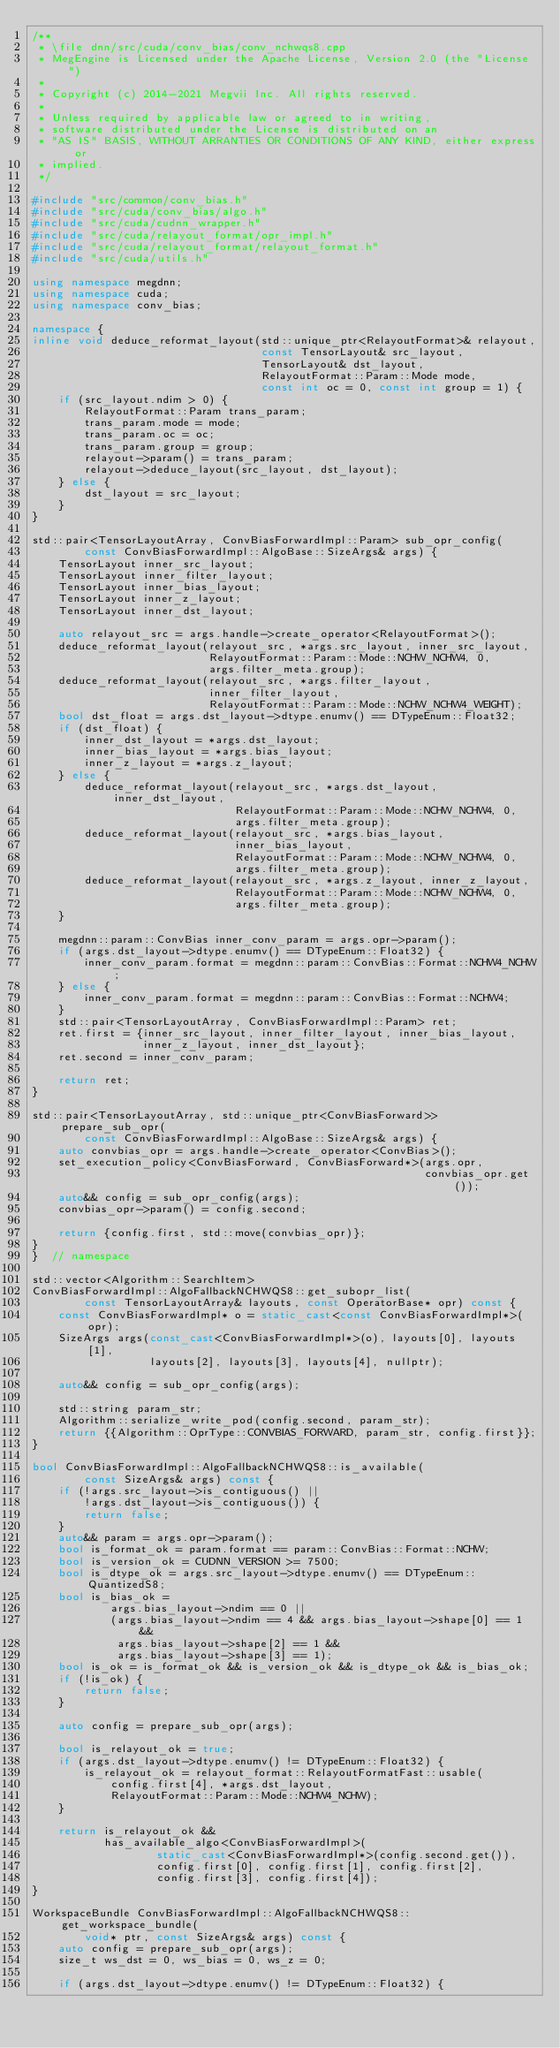Convert code to text. <code><loc_0><loc_0><loc_500><loc_500><_C++_>/**
 * \file dnn/src/cuda/conv_bias/conv_nchwqs8.cpp
 * MegEngine is Licensed under the Apache License, Version 2.0 (the "License")
 *
 * Copyright (c) 2014-2021 Megvii Inc. All rights reserved.
 *
 * Unless required by applicable law or agreed to in writing,
 * software distributed under the License is distributed on an
 * "AS IS" BASIS, WITHOUT ARRANTIES OR CONDITIONS OF ANY KIND, either express or
 * implied.
 */

#include "src/common/conv_bias.h"
#include "src/cuda/conv_bias/algo.h"
#include "src/cuda/cudnn_wrapper.h"
#include "src/cuda/relayout_format/opr_impl.h"
#include "src/cuda/relayout_format/relayout_format.h"
#include "src/cuda/utils.h"

using namespace megdnn;
using namespace cuda;
using namespace conv_bias;

namespace {
inline void deduce_reformat_layout(std::unique_ptr<RelayoutFormat>& relayout,
                                   const TensorLayout& src_layout,
                                   TensorLayout& dst_layout,
                                   RelayoutFormat::Param::Mode mode,
                                   const int oc = 0, const int group = 1) {
    if (src_layout.ndim > 0) {
        RelayoutFormat::Param trans_param;
        trans_param.mode = mode;
        trans_param.oc = oc;
        trans_param.group = group;
        relayout->param() = trans_param;
        relayout->deduce_layout(src_layout, dst_layout);
    } else {
        dst_layout = src_layout;
    }
}

std::pair<TensorLayoutArray, ConvBiasForwardImpl::Param> sub_opr_config(
        const ConvBiasForwardImpl::AlgoBase::SizeArgs& args) {
    TensorLayout inner_src_layout;
    TensorLayout inner_filter_layout;
    TensorLayout inner_bias_layout;
    TensorLayout inner_z_layout;
    TensorLayout inner_dst_layout;

    auto relayout_src = args.handle->create_operator<RelayoutFormat>();
    deduce_reformat_layout(relayout_src, *args.src_layout, inner_src_layout,
                           RelayoutFormat::Param::Mode::NCHW_NCHW4, 0,
                           args.filter_meta.group);
    deduce_reformat_layout(relayout_src, *args.filter_layout,
                           inner_filter_layout,
                           RelayoutFormat::Param::Mode::NCHW_NCHW4_WEIGHT);
    bool dst_float = args.dst_layout->dtype.enumv() == DTypeEnum::Float32;
    if (dst_float) {
        inner_dst_layout = *args.dst_layout;
        inner_bias_layout = *args.bias_layout;
        inner_z_layout = *args.z_layout;
    } else {
        deduce_reformat_layout(relayout_src, *args.dst_layout, inner_dst_layout,
                               RelayoutFormat::Param::Mode::NCHW_NCHW4, 0,
                               args.filter_meta.group);
        deduce_reformat_layout(relayout_src, *args.bias_layout,
                               inner_bias_layout,
                               RelayoutFormat::Param::Mode::NCHW_NCHW4, 0,
                               args.filter_meta.group);
        deduce_reformat_layout(relayout_src, *args.z_layout, inner_z_layout,
                               RelayoutFormat::Param::Mode::NCHW_NCHW4, 0,
                               args.filter_meta.group);
    }

    megdnn::param::ConvBias inner_conv_param = args.opr->param();
    if (args.dst_layout->dtype.enumv() == DTypeEnum::Float32) {
        inner_conv_param.format = megdnn::param::ConvBias::Format::NCHW4_NCHW;
    } else {
        inner_conv_param.format = megdnn::param::ConvBias::Format::NCHW4;
    }
    std::pair<TensorLayoutArray, ConvBiasForwardImpl::Param> ret;
    ret.first = {inner_src_layout, inner_filter_layout, inner_bias_layout,
                 inner_z_layout, inner_dst_layout};
    ret.second = inner_conv_param;

    return ret;
}

std::pair<TensorLayoutArray, std::unique_ptr<ConvBiasForward>> prepare_sub_opr(
        const ConvBiasForwardImpl::AlgoBase::SizeArgs& args) {
    auto convbias_opr = args.handle->create_operator<ConvBias>();
    set_execution_policy<ConvBiasForward, ConvBiasForward*>(args.opr,
                                                            convbias_opr.get());
    auto&& config = sub_opr_config(args);
    convbias_opr->param() = config.second;

    return {config.first, std::move(convbias_opr)};
}
}  // namespace

std::vector<Algorithm::SearchItem>
ConvBiasForwardImpl::AlgoFallbackNCHWQS8::get_subopr_list(
        const TensorLayoutArray& layouts, const OperatorBase* opr) const {
    const ConvBiasForwardImpl* o = static_cast<const ConvBiasForwardImpl*>(opr);
    SizeArgs args(const_cast<ConvBiasForwardImpl*>(o), layouts[0], layouts[1],
                  layouts[2], layouts[3], layouts[4], nullptr);

    auto&& config = sub_opr_config(args);

    std::string param_str;
    Algorithm::serialize_write_pod(config.second, param_str);
    return {{Algorithm::OprType::CONVBIAS_FORWARD, param_str, config.first}};
}

bool ConvBiasForwardImpl::AlgoFallbackNCHWQS8::is_available(
        const SizeArgs& args) const {
    if (!args.src_layout->is_contiguous() ||
        !args.dst_layout->is_contiguous()) {
        return false;
    }
    auto&& param = args.opr->param();
    bool is_format_ok = param.format == param::ConvBias::Format::NCHW;
    bool is_version_ok = CUDNN_VERSION >= 7500;
    bool is_dtype_ok = args.src_layout->dtype.enumv() == DTypeEnum::QuantizedS8;
    bool is_bias_ok =
            args.bias_layout->ndim == 0 ||
            (args.bias_layout->ndim == 4 && args.bias_layout->shape[0] == 1 &&
             args.bias_layout->shape[2] == 1 &&
             args.bias_layout->shape[3] == 1);
    bool is_ok = is_format_ok && is_version_ok && is_dtype_ok && is_bias_ok;
    if (!is_ok) {
        return false;
    }

    auto config = prepare_sub_opr(args);

    bool is_relayout_ok = true;
    if (args.dst_layout->dtype.enumv() != DTypeEnum::Float32) {
        is_relayout_ok = relayout_format::RelayoutFormatFast::usable(
            config.first[4], *args.dst_layout,
            RelayoutFormat::Param::Mode::NCHW4_NCHW);
    }

    return is_relayout_ok &&
           has_available_algo<ConvBiasForwardImpl>(
                   static_cast<ConvBiasForwardImpl*>(config.second.get()),
                   config.first[0], config.first[1], config.first[2],
                   config.first[3], config.first[4]);
}

WorkspaceBundle ConvBiasForwardImpl::AlgoFallbackNCHWQS8::get_workspace_bundle(
        void* ptr, const SizeArgs& args) const {
    auto config = prepare_sub_opr(args);
    size_t ws_dst = 0, ws_bias = 0, ws_z = 0;

    if (args.dst_layout->dtype.enumv() != DTypeEnum::Float32) {</code> 